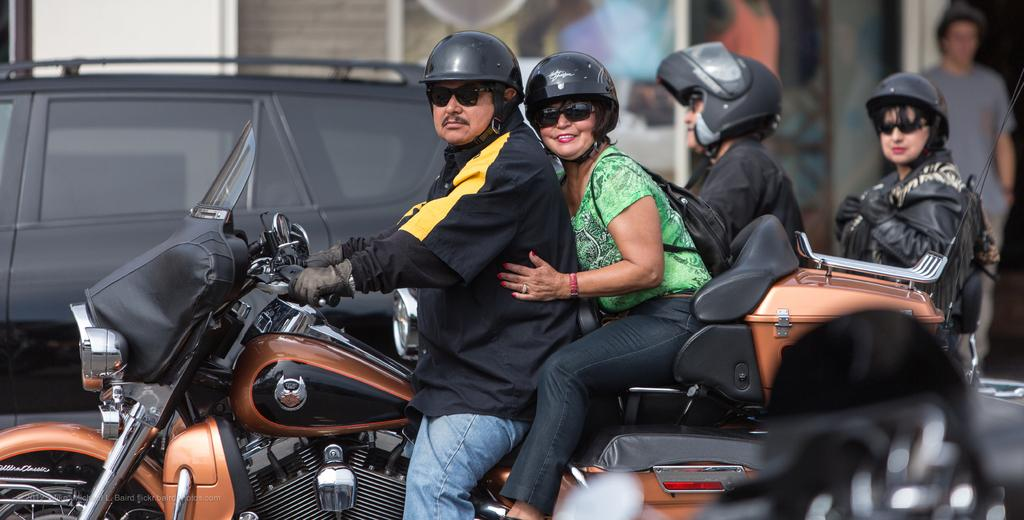Who can be seen in the image? There is a man and a woman in the image. What are they doing in the image? They are traveling on a bike. What can be seen in the background of the image? There is another man and woman, a car, and a wall in the background. What type of list can be seen hanging on the wall in the image? There is no list present in the image; the wall is mentioned as a background element, but no specific items are described. 